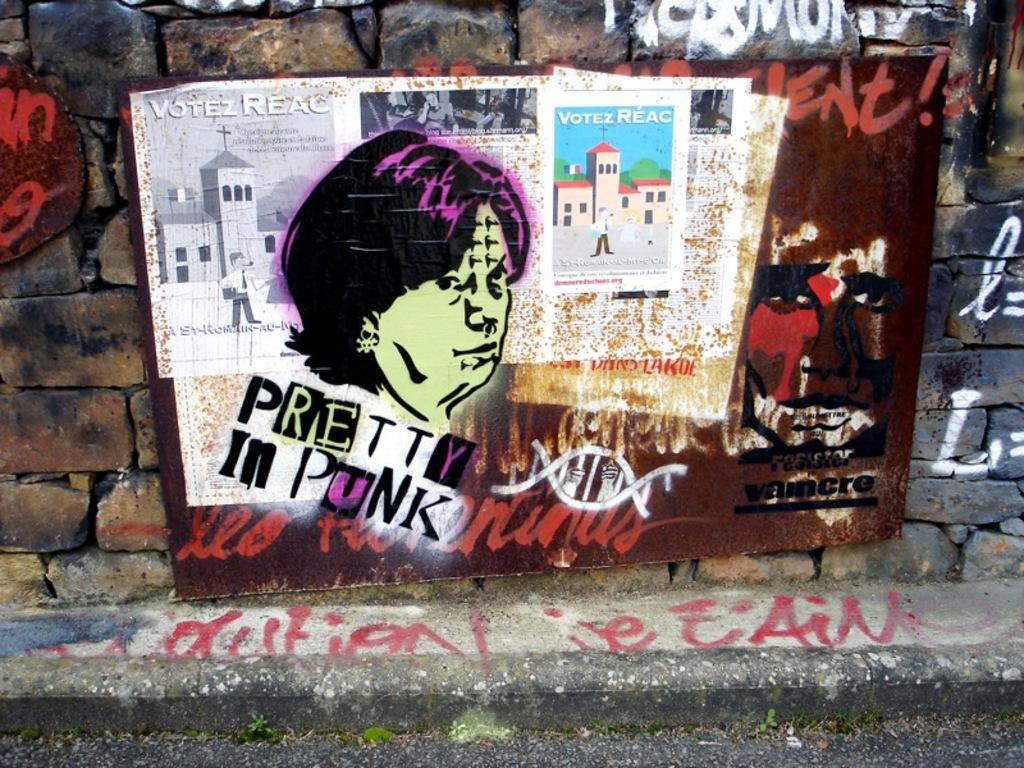Provide a one-sentence caption for the provided image. Graffiti pictures and the words "pretty in punk" on an outside wall. 